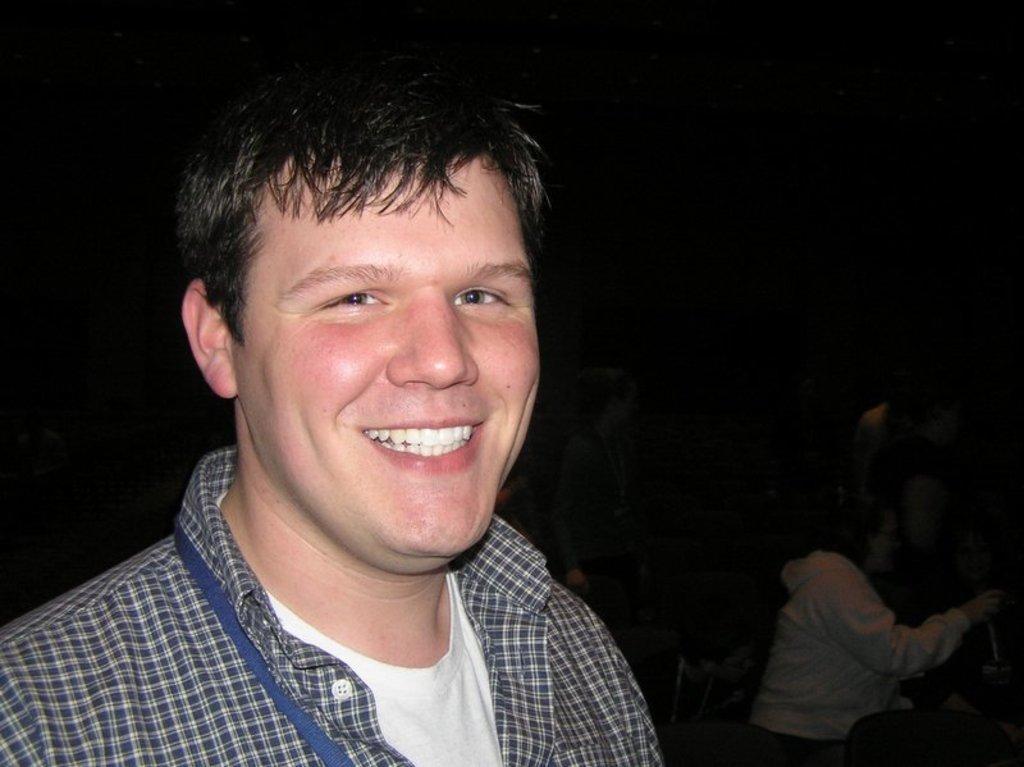How would you summarize this image in a sentence or two? In the image at the left side there is a man with black checks shirt and white t-shirt is smiling. At the right bottom of the image there are few people. And there is a black background. 